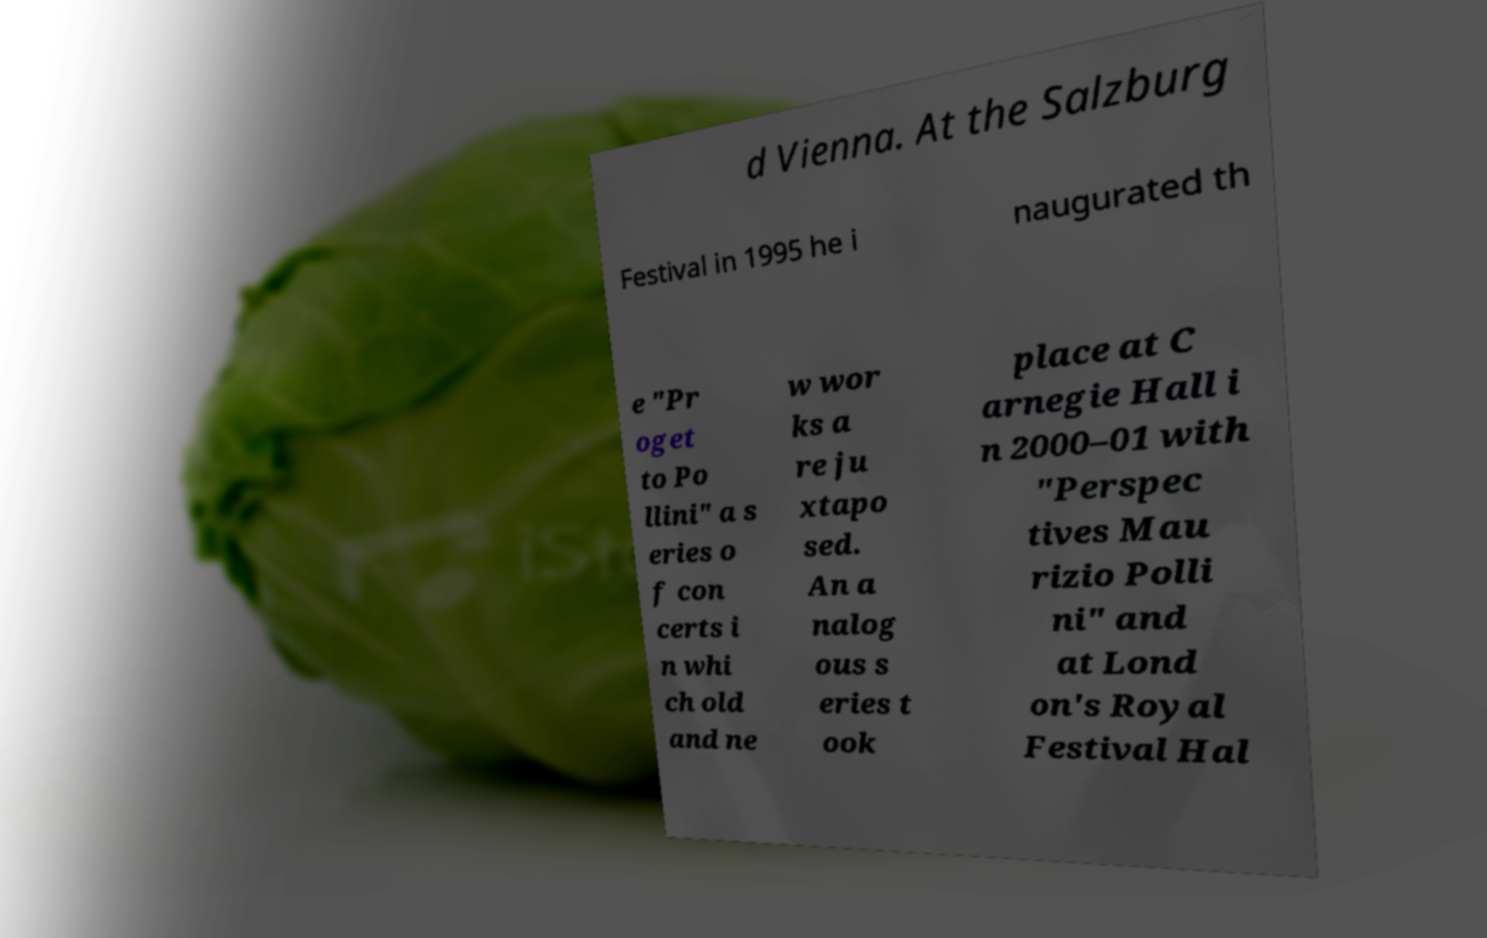Please read and relay the text visible in this image. What does it say? d Vienna. At the Salzburg Festival in 1995 he i naugurated th e "Pr oget to Po llini" a s eries o f con certs i n whi ch old and ne w wor ks a re ju xtapo sed. An a nalog ous s eries t ook place at C arnegie Hall i n 2000–01 with "Perspec tives Mau rizio Polli ni" and at Lond on's Royal Festival Hal 